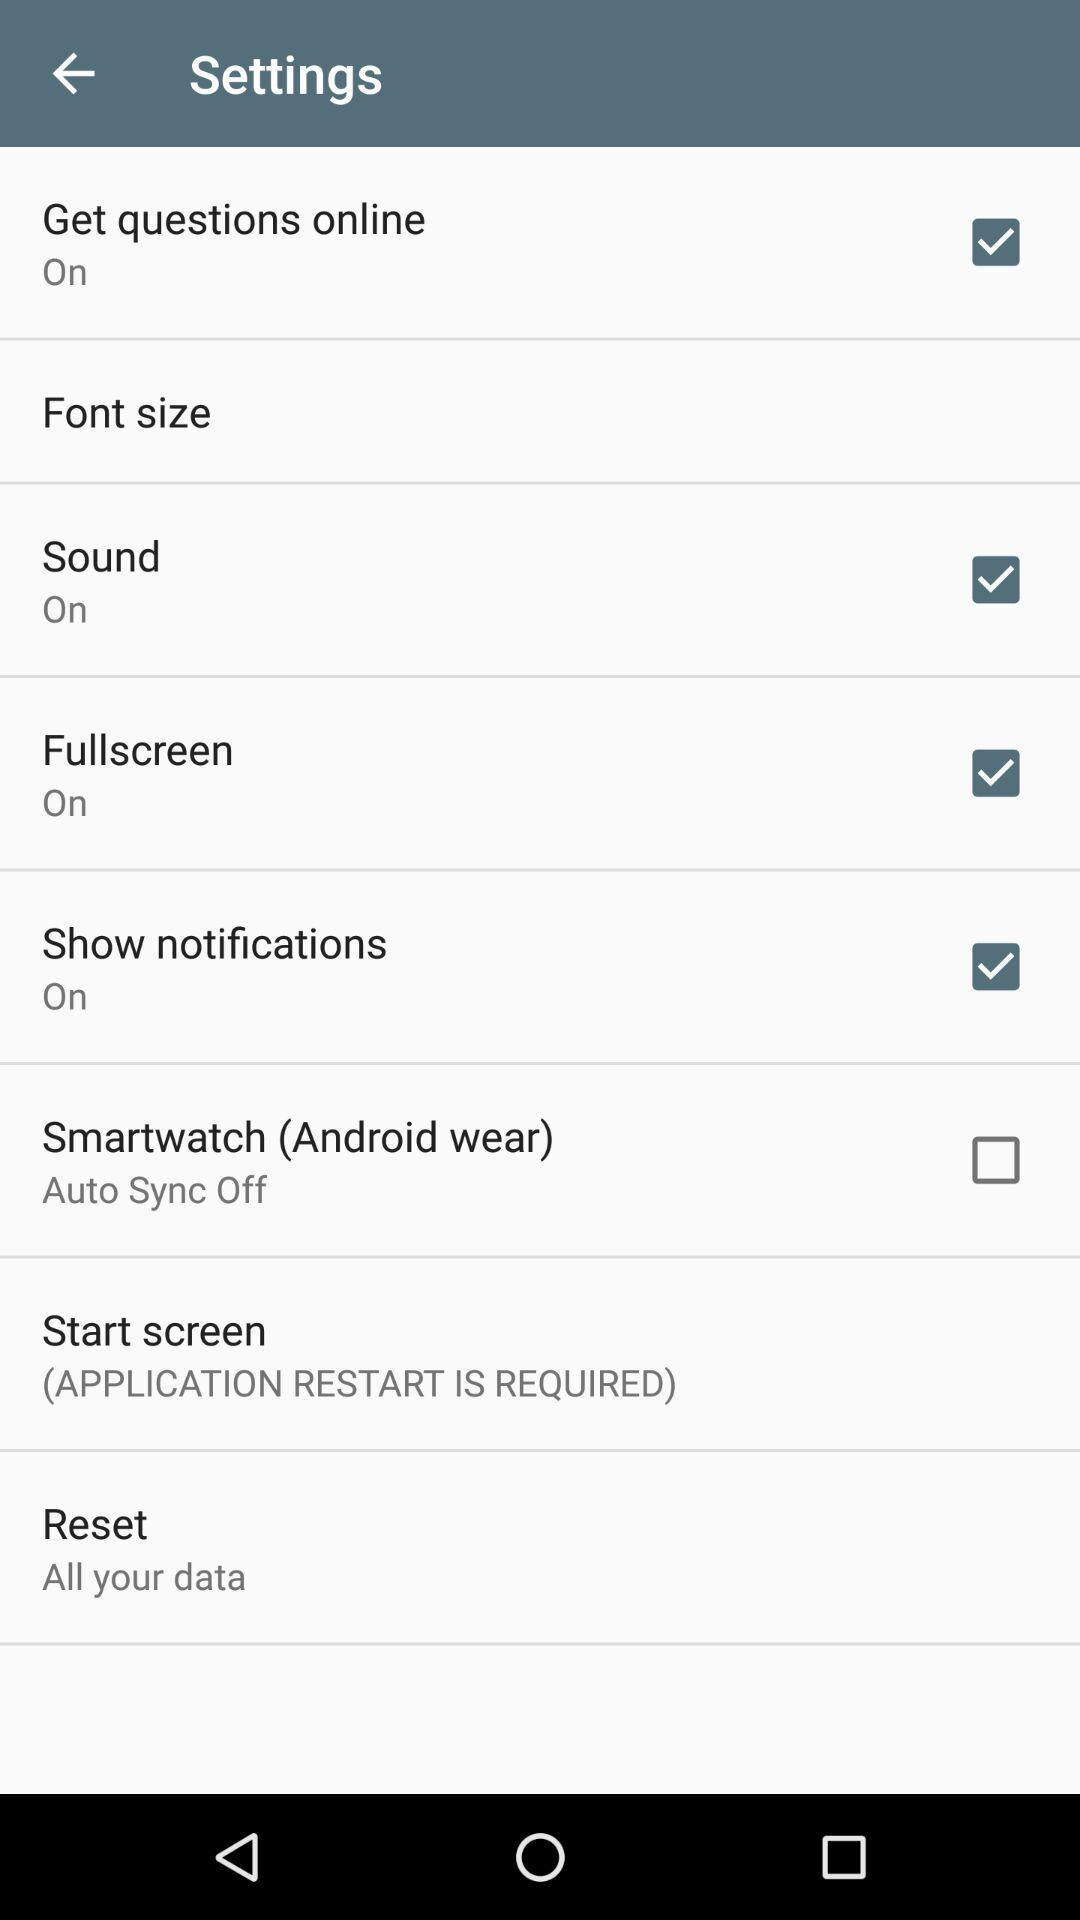Which settings are checked? The checked settings are "Get questions online", "Sound", "Fullscreen" and "Show notifications". 